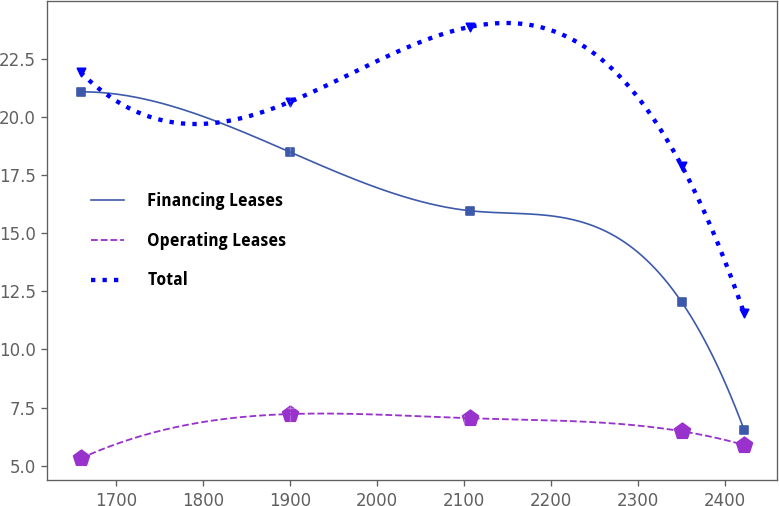Convert chart. <chart><loc_0><loc_0><loc_500><loc_500><line_chart><ecel><fcel>Financing Leases<fcel>Operating Leases<fcel>Total<nl><fcel>1659.47<fcel>21.09<fcel>5.31<fcel>21.93<nl><fcel>1899.99<fcel>18.5<fcel>7.22<fcel>20.66<nl><fcel>2107.17<fcel>15.97<fcel>7.04<fcel>23.89<nl><fcel>2350.16<fcel>12.04<fcel>6.48<fcel>17.91<nl><fcel>2421.88<fcel>6.54<fcel>5.89<fcel>11.56<nl></chart> 